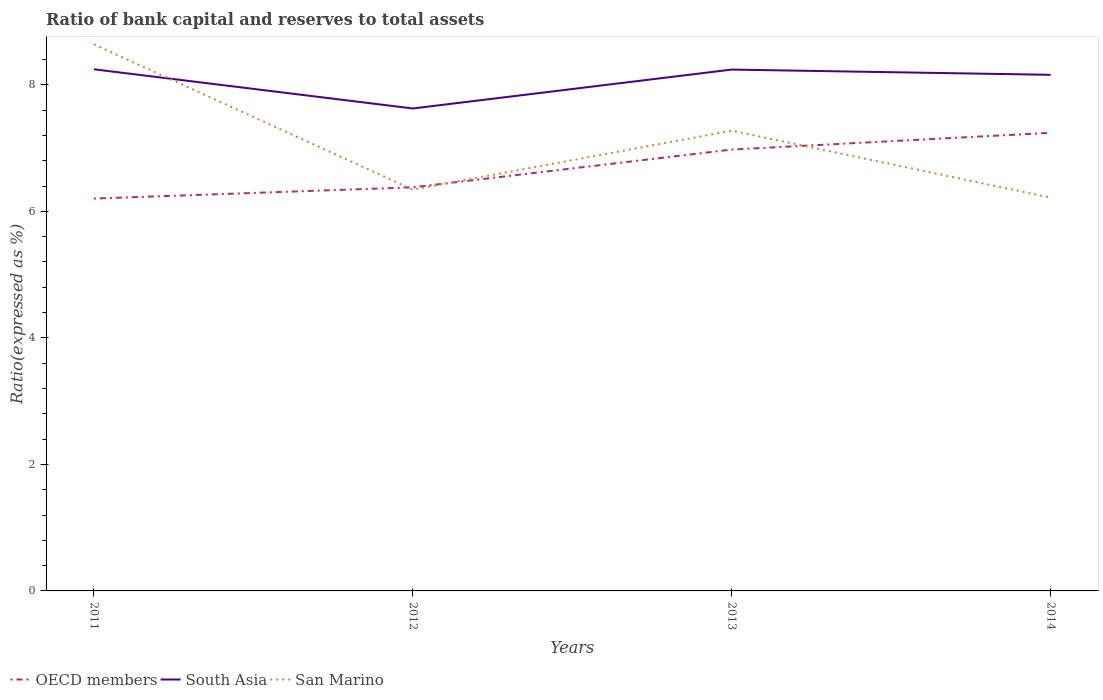Across all years, what is the maximum ratio of bank capital and reserves to total assets in South Asia?
Offer a terse response. 7.63. What is the total ratio of bank capital and reserves to total assets in San Marino in the graph?
Ensure brevity in your answer.  2.3. What is the difference between the highest and the second highest ratio of bank capital and reserves to total assets in San Marino?
Provide a short and direct response. 2.42. Is the ratio of bank capital and reserves to total assets in South Asia strictly greater than the ratio of bank capital and reserves to total assets in San Marino over the years?
Make the answer very short. No. How many lines are there?
Offer a very short reply. 3. How many years are there in the graph?
Provide a succinct answer. 4. Are the values on the major ticks of Y-axis written in scientific E-notation?
Keep it short and to the point. No. Does the graph contain any zero values?
Provide a succinct answer. No. Where does the legend appear in the graph?
Provide a short and direct response. Bottom left. How are the legend labels stacked?
Provide a succinct answer. Horizontal. What is the title of the graph?
Keep it short and to the point. Ratio of bank capital and reserves to total assets. What is the label or title of the Y-axis?
Provide a short and direct response. Ratio(expressed as %). What is the Ratio(expressed as %) of OECD members in 2011?
Give a very brief answer. 6.2. What is the Ratio(expressed as %) in South Asia in 2011?
Keep it short and to the point. 8.25. What is the Ratio(expressed as %) in San Marino in 2011?
Give a very brief answer. 8.64. What is the Ratio(expressed as %) in OECD members in 2012?
Offer a very short reply. 6.38. What is the Ratio(expressed as %) in South Asia in 2012?
Provide a succinct answer. 7.63. What is the Ratio(expressed as %) in San Marino in 2012?
Ensure brevity in your answer.  6.34. What is the Ratio(expressed as %) in OECD members in 2013?
Your answer should be very brief. 6.98. What is the Ratio(expressed as %) of South Asia in 2013?
Offer a very short reply. 8.24. What is the Ratio(expressed as %) of San Marino in 2013?
Offer a terse response. 7.28. What is the Ratio(expressed as %) of OECD members in 2014?
Your answer should be compact. 7.24. What is the Ratio(expressed as %) of South Asia in 2014?
Keep it short and to the point. 8.16. What is the Ratio(expressed as %) in San Marino in 2014?
Keep it short and to the point. 6.22. Across all years, what is the maximum Ratio(expressed as %) of OECD members?
Your answer should be compact. 7.24. Across all years, what is the maximum Ratio(expressed as %) in South Asia?
Provide a succinct answer. 8.25. Across all years, what is the maximum Ratio(expressed as %) in San Marino?
Offer a terse response. 8.64. Across all years, what is the minimum Ratio(expressed as %) in OECD members?
Give a very brief answer. 6.2. Across all years, what is the minimum Ratio(expressed as %) in South Asia?
Your response must be concise. 7.63. Across all years, what is the minimum Ratio(expressed as %) in San Marino?
Make the answer very short. 6.22. What is the total Ratio(expressed as %) in OECD members in the graph?
Ensure brevity in your answer.  26.8. What is the total Ratio(expressed as %) of South Asia in the graph?
Make the answer very short. 32.27. What is the total Ratio(expressed as %) of San Marino in the graph?
Your answer should be very brief. 28.48. What is the difference between the Ratio(expressed as %) in OECD members in 2011 and that in 2012?
Make the answer very short. -0.18. What is the difference between the Ratio(expressed as %) in South Asia in 2011 and that in 2012?
Keep it short and to the point. 0.62. What is the difference between the Ratio(expressed as %) of San Marino in 2011 and that in 2012?
Give a very brief answer. 2.3. What is the difference between the Ratio(expressed as %) of OECD members in 2011 and that in 2013?
Offer a terse response. -0.77. What is the difference between the Ratio(expressed as %) of South Asia in 2011 and that in 2013?
Offer a terse response. 0. What is the difference between the Ratio(expressed as %) of San Marino in 2011 and that in 2013?
Make the answer very short. 1.37. What is the difference between the Ratio(expressed as %) in OECD members in 2011 and that in 2014?
Your answer should be compact. -1.04. What is the difference between the Ratio(expressed as %) of South Asia in 2011 and that in 2014?
Offer a terse response. 0.09. What is the difference between the Ratio(expressed as %) of San Marino in 2011 and that in 2014?
Make the answer very short. 2.42. What is the difference between the Ratio(expressed as %) in OECD members in 2012 and that in 2013?
Ensure brevity in your answer.  -0.6. What is the difference between the Ratio(expressed as %) of South Asia in 2012 and that in 2013?
Ensure brevity in your answer.  -0.61. What is the difference between the Ratio(expressed as %) of San Marino in 2012 and that in 2013?
Your answer should be very brief. -0.93. What is the difference between the Ratio(expressed as %) of OECD members in 2012 and that in 2014?
Your response must be concise. -0.86. What is the difference between the Ratio(expressed as %) of South Asia in 2012 and that in 2014?
Your answer should be compact. -0.53. What is the difference between the Ratio(expressed as %) of San Marino in 2012 and that in 2014?
Give a very brief answer. 0.13. What is the difference between the Ratio(expressed as %) in OECD members in 2013 and that in 2014?
Ensure brevity in your answer.  -0.27. What is the difference between the Ratio(expressed as %) of South Asia in 2013 and that in 2014?
Keep it short and to the point. 0.08. What is the difference between the Ratio(expressed as %) of San Marino in 2013 and that in 2014?
Give a very brief answer. 1.06. What is the difference between the Ratio(expressed as %) in OECD members in 2011 and the Ratio(expressed as %) in South Asia in 2012?
Ensure brevity in your answer.  -1.42. What is the difference between the Ratio(expressed as %) of OECD members in 2011 and the Ratio(expressed as %) of San Marino in 2012?
Your response must be concise. -0.14. What is the difference between the Ratio(expressed as %) of South Asia in 2011 and the Ratio(expressed as %) of San Marino in 2012?
Provide a succinct answer. 1.9. What is the difference between the Ratio(expressed as %) in OECD members in 2011 and the Ratio(expressed as %) in South Asia in 2013?
Your response must be concise. -2.04. What is the difference between the Ratio(expressed as %) in OECD members in 2011 and the Ratio(expressed as %) in San Marino in 2013?
Make the answer very short. -1.07. What is the difference between the Ratio(expressed as %) of South Asia in 2011 and the Ratio(expressed as %) of San Marino in 2013?
Provide a short and direct response. 0.97. What is the difference between the Ratio(expressed as %) of OECD members in 2011 and the Ratio(expressed as %) of South Asia in 2014?
Your answer should be very brief. -1.96. What is the difference between the Ratio(expressed as %) in OECD members in 2011 and the Ratio(expressed as %) in San Marino in 2014?
Offer a very short reply. -0.01. What is the difference between the Ratio(expressed as %) in South Asia in 2011 and the Ratio(expressed as %) in San Marino in 2014?
Provide a short and direct response. 2.03. What is the difference between the Ratio(expressed as %) of OECD members in 2012 and the Ratio(expressed as %) of South Asia in 2013?
Provide a short and direct response. -1.86. What is the difference between the Ratio(expressed as %) in OECD members in 2012 and the Ratio(expressed as %) in San Marino in 2013?
Give a very brief answer. -0.9. What is the difference between the Ratio(expressed as %) of South Asia in 2012 and the Ratio(expressed as %) of San Marino in 2013?
Offer a terse response. 0.35. What is the difference between the Ratio(expressed as %) in OECD members in 2012 and the Ratio(expressed as %) in South Asia in 2014?
Provide a succinct answer. -1.78. What is the difference between the Ratio(expressed as %) in OECD members in 2012 and the Ratio(expressed as %) in San Marino in 2014?
Make the answer very short. 0.16. What is the difference between the Ratio(expressed as %) of South Asia in 2012 and the Ratio(expressed as %) of San Marino in 2014?
Your answer should be very brief. 1.41. What is the difference between the Ratio(expressed as %) in OECD members in 2013 and the Ratio(expressed as %) in South Asia in 2014?
Offer a terse response. -1.18. What is the difference between the Ratio(expressed as %) in OECD members in 2013 and the Ratio(expressed as %) in San Marino in 2014?
Make the answer very short. 0.76. What is the difference between the Ratio(expressed as %) in South Asia in 2013 and the Ratio(expressed as %) in San Marino in 2014?
Keep it short and to the point. 2.02. What is the average Ratio(expressed as %) in South Asia per year?
Make the answer very short. 8.07. What is the average Ratio(expressed as %) in San Marino per year?
Offer a terse response. 7.12. In the year 2011, what is the difference between the Ratio(expressed as %) in OECD members and Ratio(expressed as %) in South Asia?
Provide a succinct answer. -2.04. In the year 2011, what is the difference between the Ratio(expressed as %) of OECD members and Ratio(expressed as %) of San Marino?
Provide a short and direct response. -2.44. In the year 2011, what is the difference between the Ratio(expressed as %) in South Asia and Ratio(expressed as %) in San Marino?
Offer a terse response. -0.4. In the year 2012, what is the difference between the Ratio(expressed as %) of OECD members and Ratio(expressed as %) of South Asia?
Provide a short and direct response. -1.25. In the year 2012, what is the difference between the Ratio(expressed as %) of OECD members and Ratio(expressed as %) of San Marino?
Provide a succinct answer. 0.04. In the year 2012, what is the difference between the Ratio(expressed as %) in South Asia and Ratio(expressed as %) in San Marino?
Your answer should be compact. 1.28. In the year 2013, what is the difference between the Ratio(expressed as %) in OECD members and Ratio(expressed as %) in South Asia?
Provide a succinct answer. -1.26. In the year 2013, what is the difference between the Ratio(expressed as %) of OECD members and Ratio(expressed as %) of San Marino?
Offer a terse response. -0.3. In the year 2013, what is the difference between the Ratio(expressed as %) of South Asia and Ratio(expressed as %) of San Marino?
Make the answer very short. 0.97. In the year 2014, what is the difference between the Ratio(expressed as %) in OECD members and Ratio(expressed as %) in South Asia?
Give a very brief answer. -0.92. In the year 2014, what is the difference between the Ratio(expressed as %) of OECD members and Ratio(expressed as %) of San Marino?
Your answer should be very brief. 1.02. In the year 2014, what is the difference between the Ratio(expressed as %) in South Asia and Ratio(expressed as %) in San Marino?
Offer a terse response. 1.94. What is the ratio of the Ratio(expressed as %) of OECD members in 2011 to that in 2012?
Offer a terse response. 0.97. What is the ratio of the Ratio(expressed as %) in South Asia in 2011 to that in 2012?
Provide a short and direct response. 1.08. What is the ratio of the Ratio(expressed as %) in San Marino in 2011 to that in 2012?
Offer a terse response. 1.36. What is the ratio of the Ratio(expressed as %) of OECD members in 2011 to that in 2013?
Give a very brief answer. 0.89. What is the ratio of the Ratio(expressed as %) of South Asia in 2011 to that in 2013?
Offer a terse response. 1. What is the ratio of the Ratio(expressed as %) of San Marino in 2011 to that in 2013?
Make the answer very short. 1.19. What is the ratio of the Ratio(expressed as %) of OECD members in 2011 to that in 2014?
Your answer should be very brief. 0.86. What is the ratio of the Ratio(expressed as %) of South Asia in 2011 to that in 2014?
Keep it short and to the point. 1.01. What is the ratio of the Ratio(expressed as %) in San Marino in 2011 to that in 2014?
Make the answer very short. 1.39. What is the ratio of the Ratio(expressed as %) in OECD members in 2012 to that in 2013?
Provide a short and direct response. 0.91. What is the ratio of the Ratio(expressed as %) in South Asia in 2012 to that in 2013?
Ensure brevity in your answer.  0.93. What is the ratio of the Ratio(expressed as %) of San Marino in 2012 to that in 2013?
Provide a succinct answer. 0.87. What is the ratio of the Ratio(expressed as %) in OECD members in 2012 to that in 2014?
Offer a very short reply. 0.88. What is the ratio of the Ratio(expressed as %) in South Asia in 2012 to that in 2014?
Keep it short and to the point. 0.93. What is the ratio of the Ratio(expressed as %) of San Marino in 2012 to that in 2014?
Keep it short and to the point. 1.02. What is the ratio of the Ratio(expressed as %) in OECD members in 2013 to that in 2014?
Give a very brief answer. 0.96. What is the ratio of the Ratio(expressed as %) of South Asia in 2013 to that in 2014?
Keep it short and to the point. 1.01. What is the ratio of the Ratio(expressed as %) in San Marino in 2013 to that in 2014?
Offer a terse response. 1.17. What is the difference between the highest and the second highest Ratio(expressed as %) of OECD members?
Keep it short and to the point. 0.27. What is the difference between the highest and the second highest Ratio(expressed as %) in South Asia?
Your answer should be very brief. 0. What is the difference between the highest and the second highest Ratio(expressed as %) of San Marino?
Offer a terse response. 1.37. What is the difference between the highest and the lowest Ratio(expressed as %) in OECD members?
Provide a short and direct response. 1.04. What is the difference between the highest and the lowest Ratio(expressed as %) in South Asia?
Keep it short and to the point. 0.62. What is the difference between the highest and the lowest Ratio(expressed as %) of San Marino?
Make the answer very short. 2.42. 